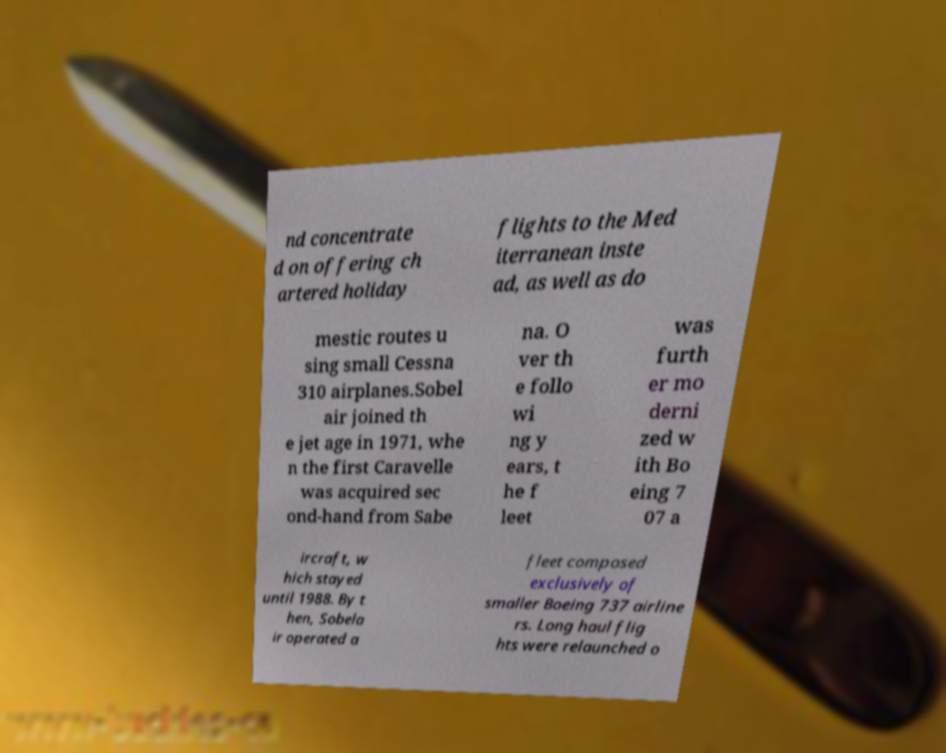Please read and relay the text visible in this image. What does it say? nd concentrate d on offering ch artered holiday flights to the Med iterranean inste ad, as well as do mestic routes u sing small Cessna 310 airplanes.Sobel air joined th e jet age in 1971, whe n the first Caravelle was acquired sec ond-hand from Sabe na. O ver th e follo wi ng y ears, t he f leet was furth er mo derni zed w ith Bo eing 7 07 a ircraft, w hich stayed until 1988. By t hen, Sobela ir operated a fleet composed exclusively of smaller Boeing 737 airline rs. Long haul flig hts were relaunched o 